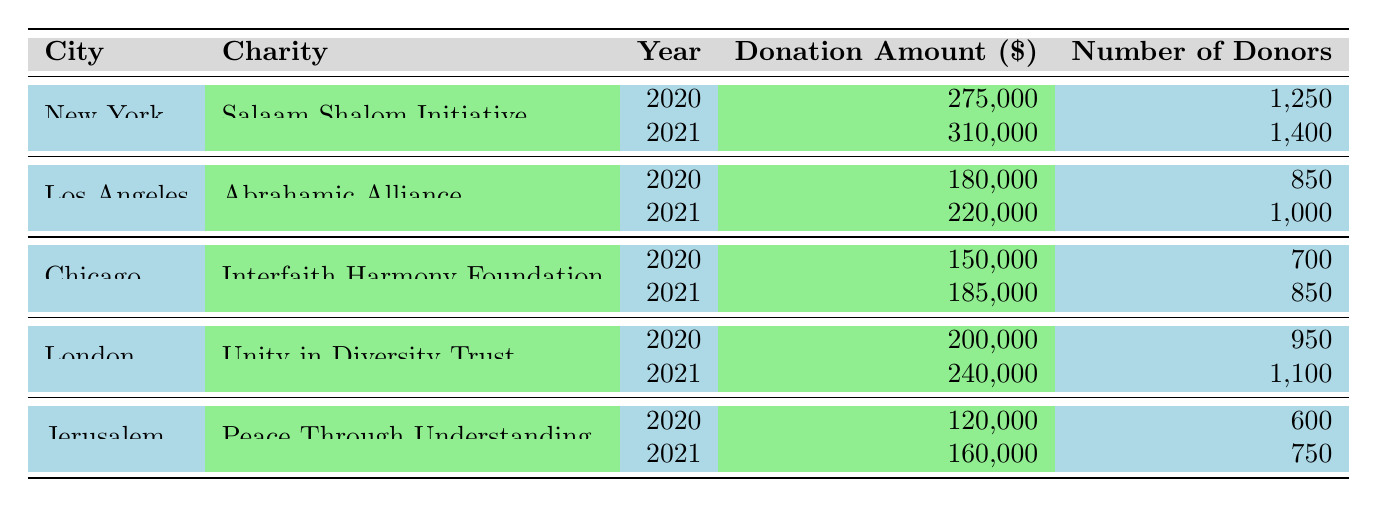What was the highest donation amount received in 2021? By examining the table, we note that the highest donation amount in 2021 is from the Salaam Shalom Initiative in New York, which is $310,000.
Answer: $310,000 Which charity had the lowest number of donors in 2020? Looking at the 2020 data, the charity with the lowest number of donors is the Peace Through Understanding in Jerusalem, with 600 donors.
Answer: 600 What is the total donation amount collected by the Abrahamic Alliance over the two years? The total donation amount for the Abrahamic Alliance is calculated by adding the donations from 2020 and 2021: $180,000 (2020) + $220,000 (2021) = $400,000.
Answer: $400,000 Did the donations increase for the Unity in Diversity Trust from 2020 to 2021? We see the donations for the Unity in Diversity Trust were $200,000 in 2020 and increased to $240,000 in 2021, indicating an increase in donations.
Answer: Yes What city had the highest total donations in the two years combined? We calculate the total donations for each city: New York: $275,000 + $310,000 = $585,000; Los Angeles: $180,000 + $220,000 = $400,000; Chicago: $150,000 + $185,000 = $335,000; London: $200,000 + $240,000 = $440,000; Jerusalem: $120,000 + $160,000 = $280,000. New York has the highest total.
Answer: New York How many donors contributed to the Interfaith Harmony Foundation in 2021? The table shows that in 2021, the Interfaith Harmony Foundation had 850 donors.
Answer: 850 What is the average donation amount across all charities in 2020? To find the average, first sum all the 2020 donations: $275,000 + $180,000 + $150,000 + $200,000 + $120,000 = $1,025,000. There are 5 charities, so the average is $1,025,000 / 5 = $205,000.
Answer: $205,000 Which charity had the greatest increase in the number of donors from 2020 to 2021? The number of donors increased for each charity: Salaam Shalom Initiative: 150; Abrahamic Alliance: 150; Interfaith Harmony Foundation: 150; Unity in Diversity Trust: 150; Peace Through Understanding: 150. All charities had an equal increase of 150 donors.
Answer: None (equal increase) What was the donation amount for the Peace Through Understanding in 2021? According to the table, the donation amount for the Peace Through Understanding charity in 2021 was $160,000.
Answer: $160,000 Did Chicago see an increase in the donation amount from 2020 to 2021? The donation amount for Chicago was $150,000 in 2020 and increased to $185,000 in 2021, indicating a positive change.
Answer: Yes 